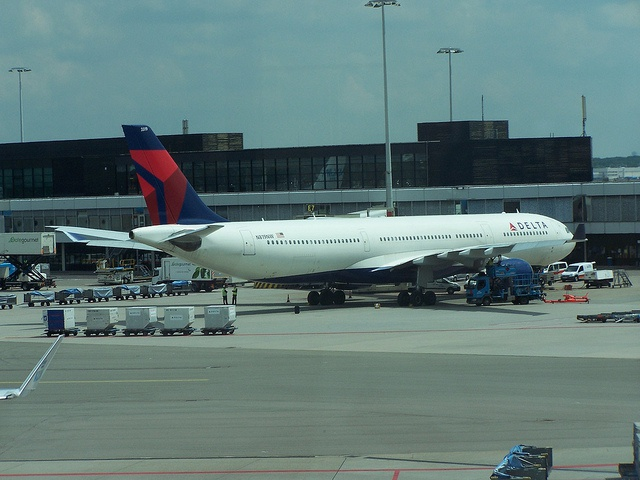Describe the objects in this image and their specific colors. I can see airplane in teal, ivory, black, lightblue, and gray tones, truck in teal, black, darkblue, blue, and gray tones, truck in teal, gray, black, and purple tones, car in teal, black, purple, and gray tones, and truck in teal, black, lightblue, and gray tones in this image. 